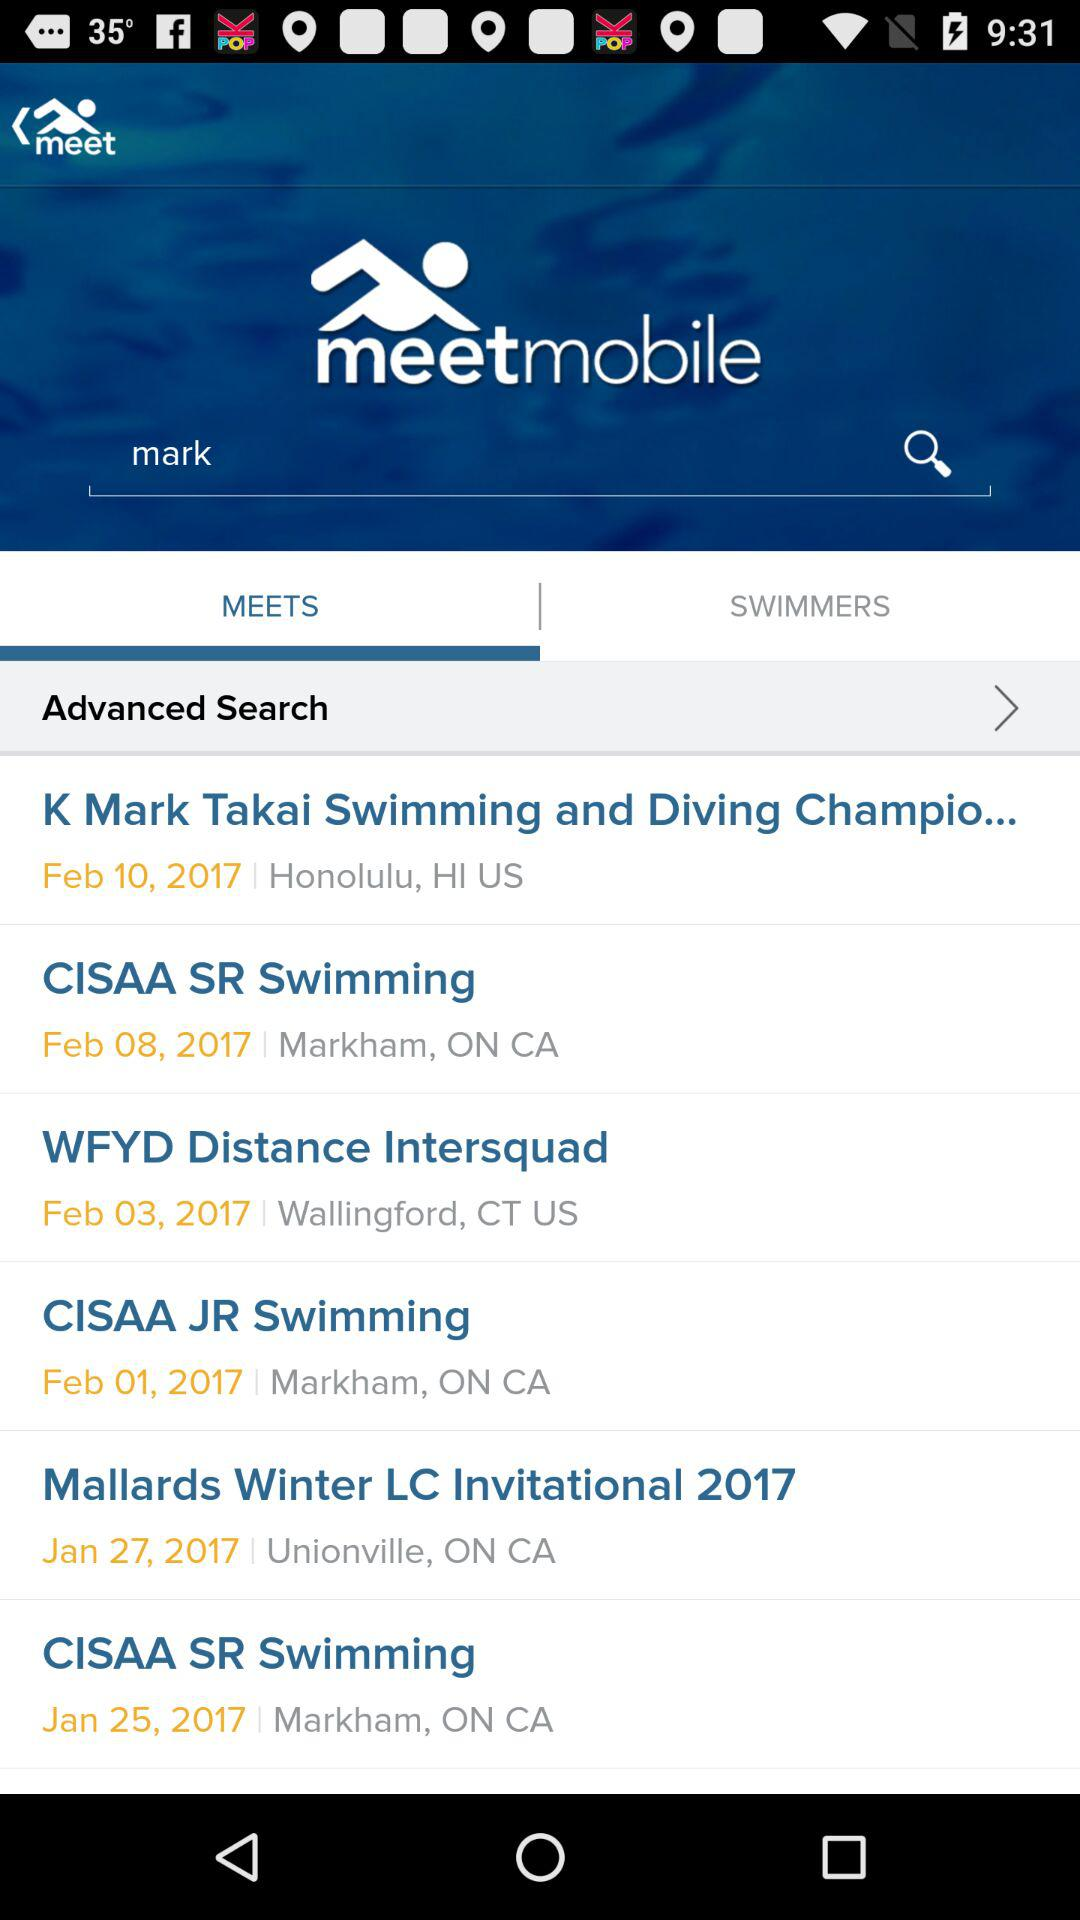What is the date of "CISAA SR Swimming"? The dates are February 8, 2017 and January 25, 2017. 